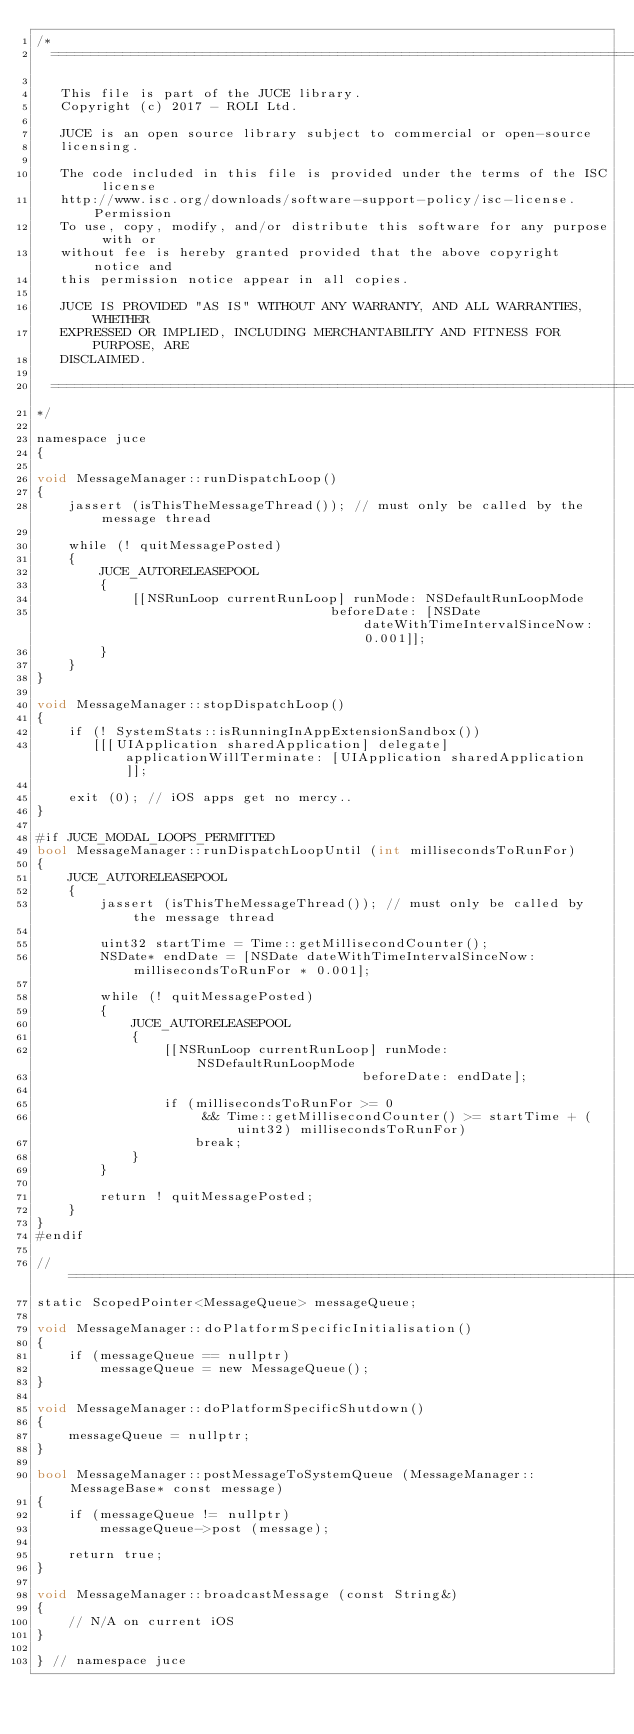<code> <loc_0><loc_0><loc_500><loc_500><_ObjectiveC_>/*
  ==============================================================================

   This file is part of the JUCE library.
   Copyright (c) 2017 - ROLI Ltd.

   JUCE is an open source library subject to commercial or open-source
   licensing.

   The code included in this file is provided under the terms of the ISC license
   http://www.isc.org/downloads/software-support-policy/isc-license. Permission
   To use, copy, modify, and/or distribute this software for any purpose with or
   without fee is hereby granted provided that the above copyright notice and
   this permission notice appear in all copies.

   JUCE IS PROVIDED "AS IS" WITHOUT ANY WARRANTY, AND ALL WARRANTIES, WHETHER
   EXPRESSED OR IMPLIED, INCLUDING MERCHANTABILITY AND FITNESS FOR PURPOSE, ARE
   DISCLAIMED.

  ==============================================================================
*/

namespace juce
{

void MessageManager::runDispatchLoop()
{
    jassert (isThisTheMessageThread()); // must only be called by the message thread

    while (! quitMessagePosted)
    {
        JUCE_AUTORELEASEPOOL
        {
            [[NSRunLoop currentRunLoop] runMode: NSDefaultRunLoopMode
                                     beforeDate: [NSDate dateWithTimeIntervalSinceNow: 0.001]];
        }
    }
}

void MessageManager::stopDispatchLoop()
{
    if (! SystemStats::isRunningInAppExtensionSandbox())
       [[[UIApplication sharedApplication] delegate] applicationWillTerminate: [UIApplication sharedApplication]];

    exit (0); // iOS apps get no mercy..
}

#if JUCE_MODAL_LOOPS_PERMITTED
bool MessageManager::runDispatchLoopUntil (int millisecondsToRunFor)
{
    JUCE_AUTORELEASEPOOL
    {
        jassert (isThisTheMessageThread()); // must only be called by the message thread

        uint32 startTime = Time::getMillisecondCounter();
        NSDate* endDate = [NSDate dateWithTimeIntervalSinceNow: millisecondsToRunFor * 0.001];

        while (! quitMessagePosted)
        {
            JUCE_AUTORELEASEPOOL
            {
                [[NSRunLoop currentRunLoop] runMode: NSDefaultRunLoopMode
                                         beforeDate: endDate];

                if (millisecondsToRunFor >= 0
                     && Time::getMillisecondCounter() >= startTime + (uint32) millisecondsToRunFor)
                    break;
            }
        }

        return ! quitMessagePosted;
    }
}
#endif

//==============================================================================
static ScopedPointer<MessageQueue> messageQueue;

void MessageManager::doPlatformSpecificInitialisation()
{
    if (messageQueue == nullptr)
        messageQueue = new MessageQueue();
}

void MessageManager::doPlatformSpecificShutdown()
{
    messageQueue = nullptr;
}

bool MessageManager::postMessageToSystemQueue (MessageManager::MessageBase* const message)
{
    if (messageQueue != nullptr)
        messageQueue->post (message);

    return true;
}

void MessageManager::broadcastMessage (const String&)
{
    // N/A on current iOS
}

} // namespace juce
</code> 